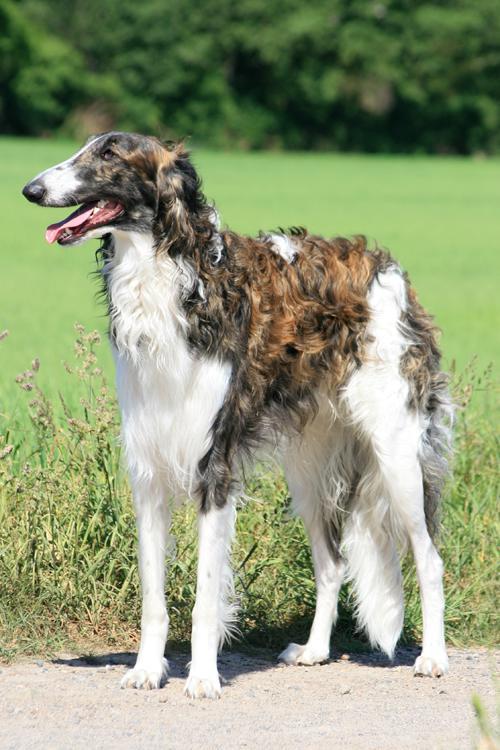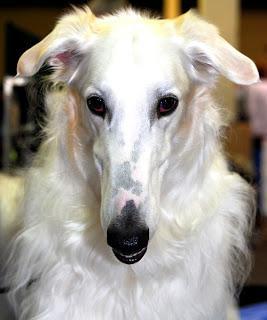The first image is the image on the left, the second image is the image on the right. Assess this claim about the two images: "All of the dogs are facing the same way.". Correct or not? Answer yes or no. No. The first image is the image on the left, the second image is the image on the right. Assess this claim about the two images: "All images show hounds standing on the grass.". Correct or not? Answer yes or no. No. 